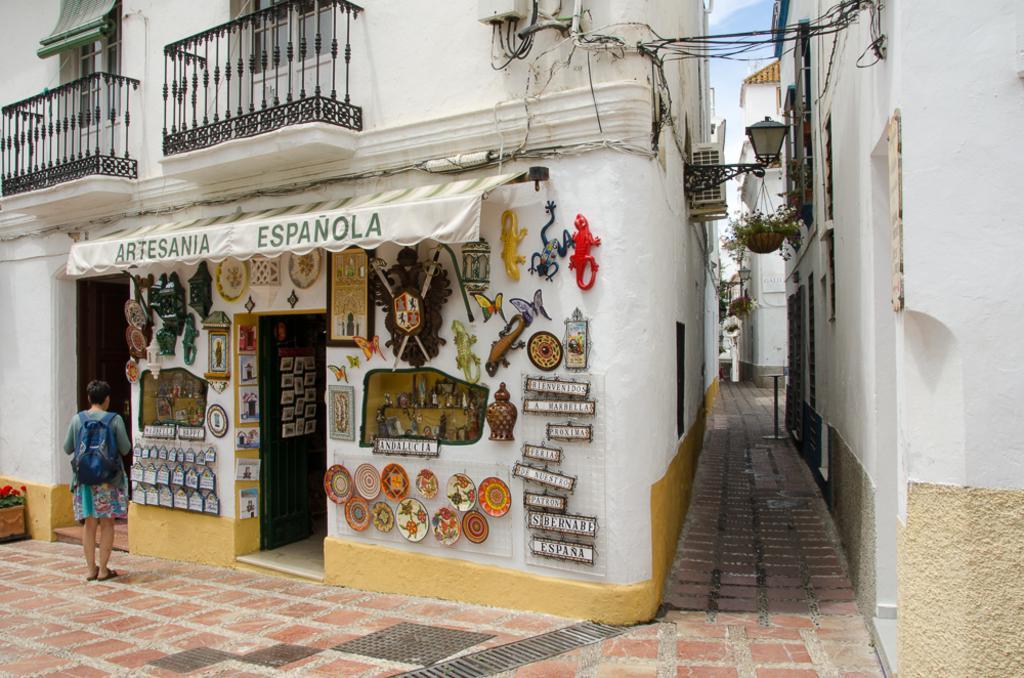Please provide a concise description of this image. To the bottom of the image there is a floor with tiles. To the left side of the image there is a person with a bag is standing. In front of that person there is a building with wall, glass windows and balcony. And also there is a store. To the walls of the stores there are plates, name plates, frames, animals and few other items on it. To the right corner of the image there is a building with walls and windows. And to the top of the image there are wires. 